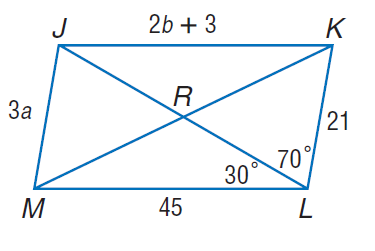Answer the mathemtical geometry problem and directly provide the correct option letter.
Question: Use parallelogram J K L M to find b if J K = 2 b + 3 and J M = 3 a.
Choices: A: 7 B: 14 C: 21 D: 45 C 